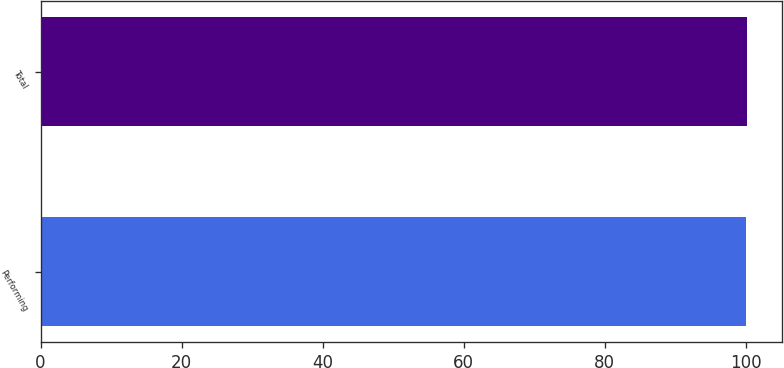<chart> <loc_0><loc_0><loc_500><loc_500><bar_chart><fcel>Performing<fcel>Total<nl><fcel>100<fcel>100.1<nl></chart> 